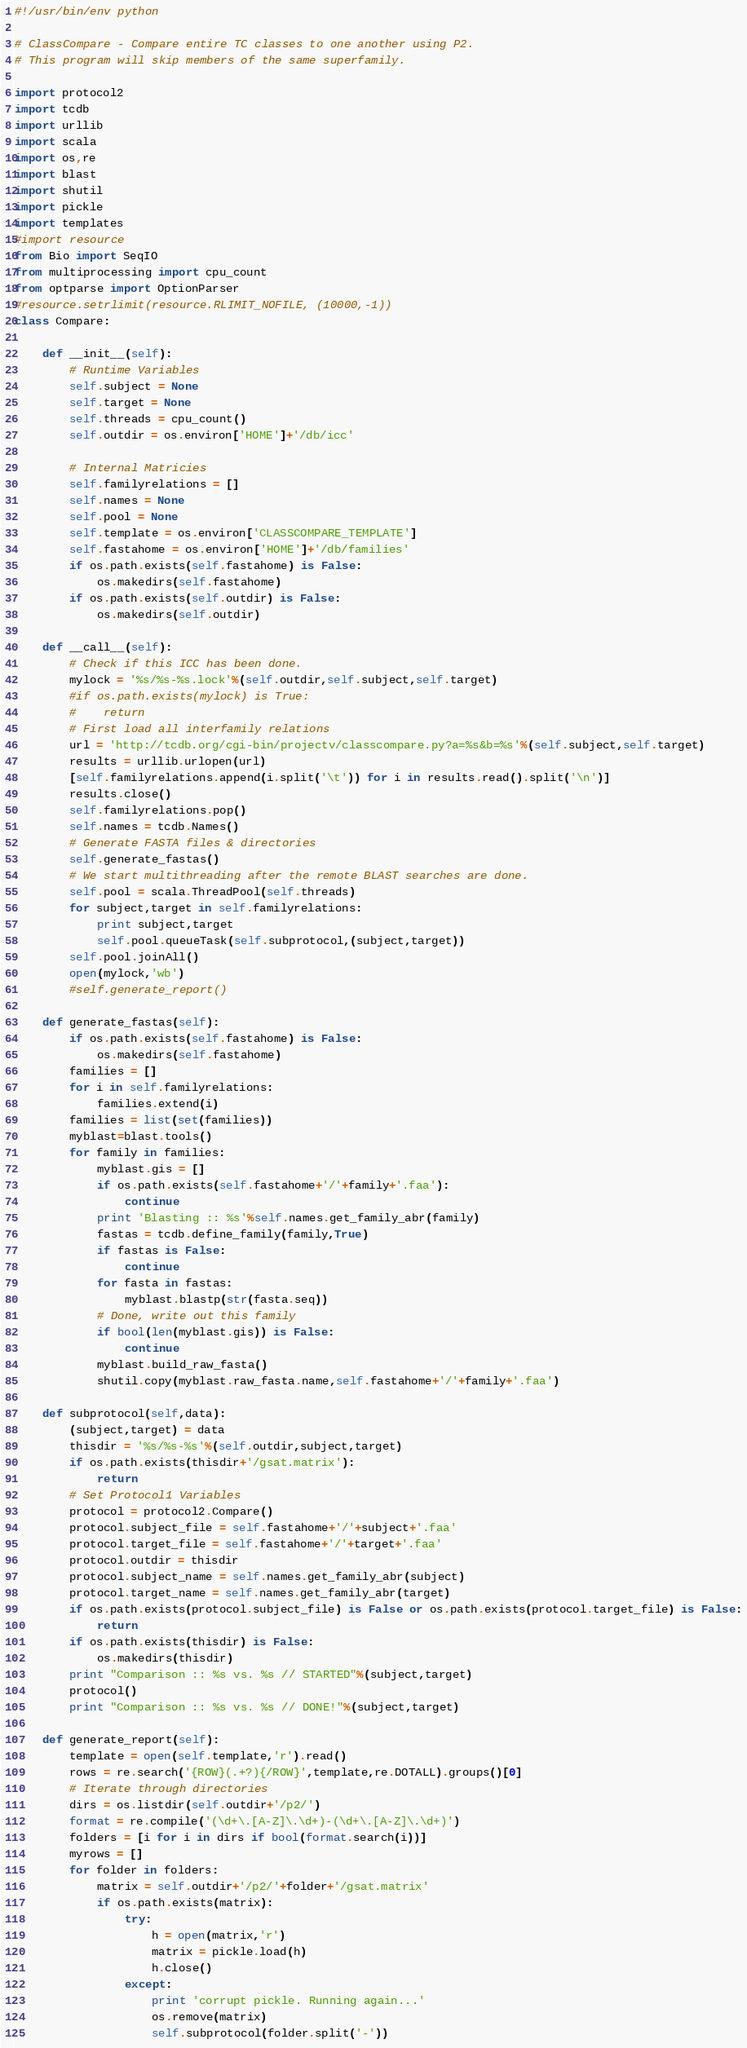<code> <loc_0><loc_0><loc_500><loc_500><_Python_>#!/usr/bin/env python

# ClassCompare - Compare entire TC classes to one another using P2.
# This program will skip members of the same superfamily.

import protocol2
import tcdb
import urllib
import scala
import os,re
import blast
import shutil
import pickle
import templates
#import resource
from Bio import SeqIO
from multiprocessing import cpu_count
from optparse import OptionParser
#resource.setrlimit(resource.RLIMIT_NOFILE, (10000,-1))
class Compare:

    def __init__(self):
        # Runtime Variables
        self.subject = None
        self.target = None
        self.threads = cpu_count()
        self.outdir = os.environ['HOME']+'/db/icc'

        # Internal Matricies
        self.familyrelations = []
        self.names = None
        self.pool = None
        self.template = os.environ['CLASSCOMPARE_TEMPLATE']
        self.fastahome = os.environ['HOME']+'/db/families'
        if os.path.exists(self.fastahome) is False:
            os.makedirs(self.fastahome)
        if os.path.exists(self.outdir) is False:
            os.makedirs(self.outdir)

    def __call__(self):
        # Check if this ICC has been done.
        mylock = '%s/%s-%s.lock'%(self.outdir,self.subject,self.target)
        #if os.path.exists(mylock) is True:
        #    return
        # First load all interfamily relations
        url = 'http://tcdb.org/cgi-bin/projectv/classcompare.py?a=%s&b=%s'%(self.subject,self.target)
        results = urllib.urlopen(url)
        [self.familyrelations.append(i.split('\t')) for i in results.read().split('\n')]
        results.close()
        self.familyrelations.pop()
        self.names = tcdb.Names()
        # Generate FASTA files & directories
        self.generate_fastas()
        # We start multithreading after the remote BLAST searches are done.
        self.pool = scala.ThreadPool(self.threads)
        for subject,target in self.familyrelations:
            print subject,target
            self.pool.queueTask(self.subprotocol,(subject,target))
        self.pool.joinAll()
        open(mylock,'wb')
        #self.generate_report()

    def generate_fastas(self):
        if os.path.exists(self.fastahome) is False:
            os.makedirs(self.fastahome)
        families = []
        for i in self.familyrelations:
            families.extend(i)
        families = list(set(families))
        myblast=blast.tools()
        for family in families:
            myblast.gis = []
            if os.path.exists(self.fastahome+'/'+family+'.faa'):
                continue
            print 'Blasting :: %s'%self.names.get_family_abr(family)
            fastas = tcdb.define_family(family,True)
            if fastas is False:
                continue
            for fasta in fastas:
                myblast.blastp(str(fasta.seq))
            # Done, write out this family
            if bool(len(myblast.gis)) is False:
                continue
            myblast.build_raw_fasta()
            shutil.copy(myblast.raw_fasta.name,self.fastahome+'/'+family+'.faa')

    def subprotocol(self,data):
        (subject,target) = data
        thisdir = '%s/%s-%s'%(self.outdir,subject,target)
        if os.path.exists(thisdir+'/gsat.matrix'):
            return
        # Set Protocol1 Variables
        protocol = protocol2.Compare()
        protocol.subject_file = self.fastahome+'/'+subject+'.faa'
        protocol.target_file = self.fastahome+'/'+target+'.faa'
        protocol.outdir = thisdir
        protocol.subject_name = self.names.get_family_abr(subject)
        protocol.target_name = self.names.get_family_abr(target)
        if os.path.exists(protocol.subject_file) is False or os.path.exists(protocol.target_file) is False:
            return
        if os.path.exists(thisdir) is False:
            os.makedirs(thisdir)
        print "Comparison :: %s vs. %s // STARTED"%(subject,target)
        protocol()
        print "Comparison :: %s vs. %s // DONE!"%(subject,target)

    def generate_report(self):
        template = open(self.template,'r').read()
        rows = re.search('{ROW}(.+?){/ROW}',template,re.DOTALL).groups()[0]
        # Iterate through directories
        dirs = os.listdir(self.outdir+'/p2/')
        format = re.compile('(\d+\.[A-Z]\.\d+)-(\d+\.[A-Z]\.\d+)')
        folders = [i for i in dirs if bool(format.search(i))]
        myrows = []
        for folder in folders:
            matrix = self.outdir+'/p2/'+folder+'/gsat.matrix'
            if os.path.exists(matrix):
                try:
                    h = open(matrix,'r')
                    matrix = pickle.load(h)
                    h.close()
                except:
                    print 'corrupt pickle. Running again...'
                    os.remove(matrix)
                    self.subprotocol(folder.split('-'))</code> 